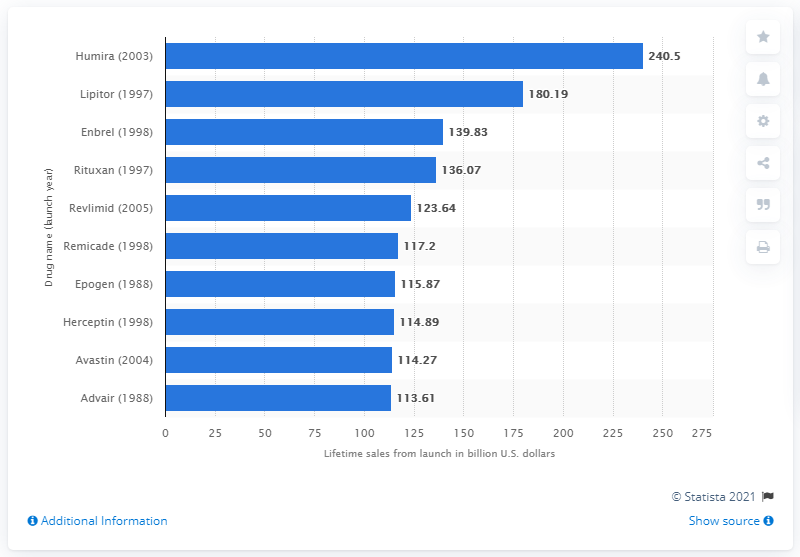Identify some key points in this picture. Lipitor is expected to generate a total of $180.19 from its launch to 2024. 